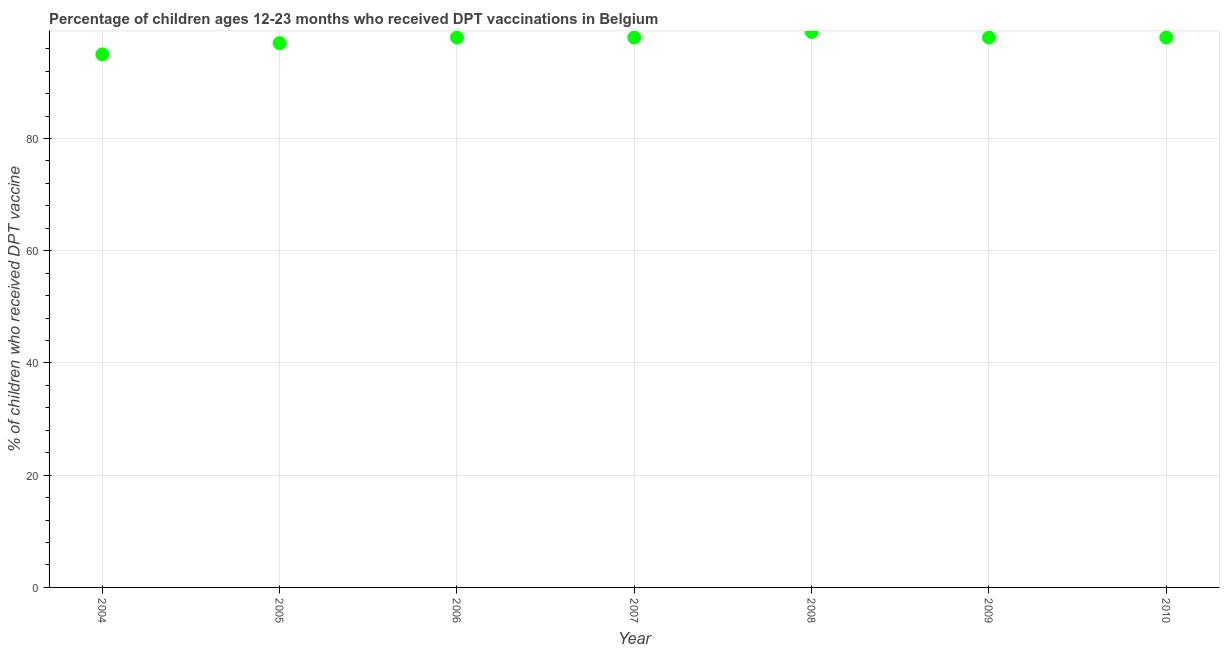What is the percentage of children who received dpt vaccine in 2006?
Give a very brief answer. 98. Across all years, what is the maximum percentage of children who received dpt vaccine?
Provide a short and direct response. 99. Across all years, what is the minimum percentage of children who received dpt vaccine?
Provide a succinct answer. 95. What is the sum of the percentage of children who received dpt vaccine?
Your answer should be very brief. 683. What is the difference between the percentage of children who received dpt vaccine in 2004 and 2008?
Offer a terse response. -4. What is the average percentage of children who received dpt vaccine per year?
Provide a short and direct response. 97.57. What is the median percentage of children who received dpt vaccine?
Make the answer very short. 98. What is the ratio of the percentage of children who received dpt vaccine in 2004 to that in 2005?
Your answer should be very brief. 0.98. What is the difference between the highest and the second highest percentage of children who received dpt vaccine?
Offer a very short reply. 1. Is the sum of the percentage of children who received dpt vaccine in 2005 and 2009 greater than the maximum percentage of children who received dpt vaccine across all years?
Provide a succinct answer. Yes. What is the difference between the highest and the lowest percentage of children who received dpt vaccine?
Provide a short and direct response. 4. In how many years, is the percentage of children who received dpt vaccine greater than the average percentage of children who received dpt vaccine taken over all years?
Offer a very short reply. 5. Does the percentage of children who received dpt vaccine monotonically increase over the years?
Offer a terse response. No. What is the difference between two consecutive major ticks on the Y-axis?
Offer a terse response. 20. Are the values on the major ticks of Y-axis written in scientific E-notation?
Offer a very short reply. No. What is the title of the graph?
Your answer should be compact. Percentage of children ages 12-23 months who received DPT vaccinations in Belgium. What is the label or title of the Y-axis?
Provide a succinct answer. % of children who received DPT vaccine. What is the % of children who received DPT vaccine in 2004?
Offer a very short reply. 95. What is the % of children who received DPT vaccine in 2005?
Your response must be concise. 97. What is the % of children who received DPT vaccine in 2006?
Your answer should be very brief. 98. What is the % of children who received DPT vaccine in 2007?
Provide a succinct answer. 98. What is the % of children who received DPT vaccine in 2009?
Give a very brief answer. 98. What is the % of children who received DPT vaccine in 2010?
Provide a succinct answer. 98. What is the difference between the % of children who received DPT vaccine in 2004 and 2006?
Offer a very short reply. -3. What is the difference between the % of children who received DPT vaccine in 2004 and 2008?
Provide a succinct answer. -4. What is the difference between the % of children who received DPT vaccine in 2004 and 2009?
Make the answer very short. -3. What is the difference between the % of children who received DPT vaccine in 2005 and 2006?
Your response must be concise. -1. What is the difference between the % of children who received DPT vaccine in 2005 and 2007?
Your answer should be very brief. -1. What is the difference between the % of children who received DPT vaccine in 2005 and 2010?
Give a very brief answer. -1. What is the difference between the % of children who received DPT vaccine in 2006 and 2008?
Your answer should be compact. -1. What is the difference between the % of children who received DPT vaccine in 2006 and 2009?
Provide a short and direct response. 0. What is the difference between the % of children who received DPT vaccine in 2006 and 2010?
Keep it short and to the point. 0. What is the difference between the % of children who received DPT vaccine in 2008 and 2009?
Your response must be concise. 1. What is the difference between the % of children who received DPT vaccine in 2008 and 2010?
Your answer should be compact. 1. What is the difference between the % of children who received DPT vaccine in 2009 and 2010?
Ensure brevity in your answer.  0. What is the ratio of the % of children who received DPT vaccine in 2004 to that in 2005?
Offer a terse response. 0.98. What is the ratio of the % of children who received DPT vaccine in 2004 to that in 2010?
Keep it short and to the point. 0.97. What is the ratio of the % of children who received DPT vaccine in 2005 to that in 2006?
Offer a terse response. 0.99. What is the ratio of the % of children who received DPT vaccine in 2005 to that in 2008?
Make the answer very short. 0.98. What is the ratio of the % of children who received DPT vaccine in 2006 to that in 2008?
Offer a very short reply. 0.99. What is the ratio of the % of children who received DPT vaccine in 2006 to that in 2009?
Your answer should be compact. 1. What is the ratio of the % of children who received DPT vaccine in 2007 to that in 2008?
Offer a very short reply. 0.99. What is the ratio of the % of children who received DPT vaccine in 2007 to that in 2010?
Your response must be concise. 1. What is the ratio of the % of children who received DPT vaccine in 2009 to that in 2010?
Your answer should be compact. 1. 